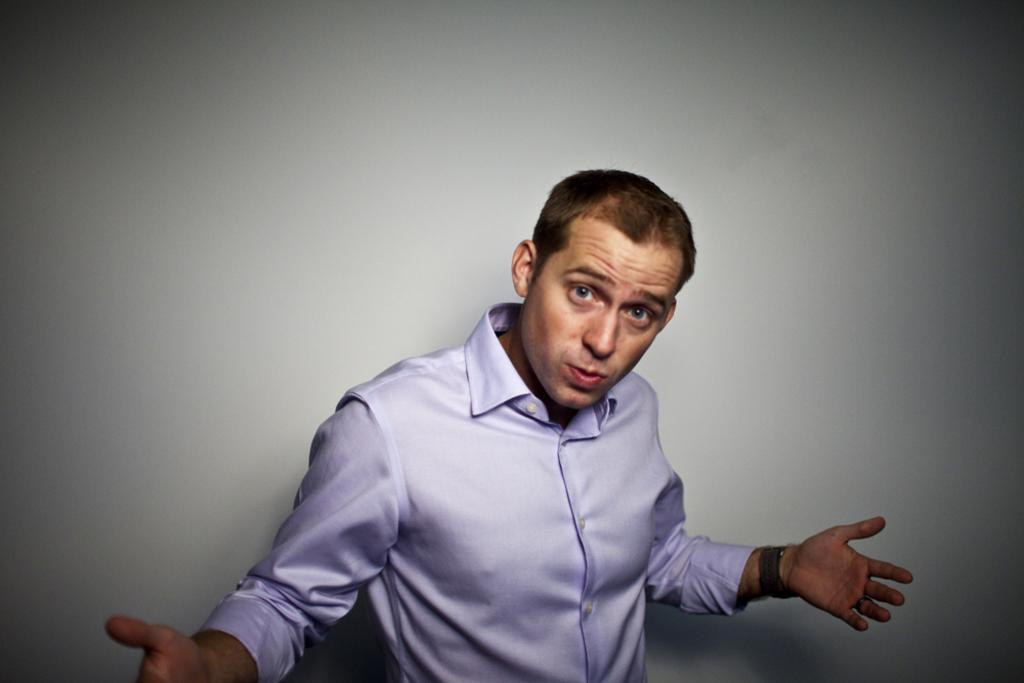Who is present in the image? There is a man in the image. What can be seen behind the man in the image? The background of the image is white. What type of songs can be heard coming from the roof in the image? There is no roof or indication of any songs in the image, as it only features a man with a white background. 